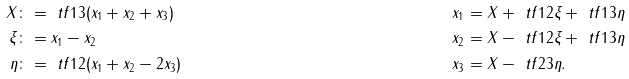Convert formula to latex. <formula><loc_0><loc_0><loc_500><loc_500>X & \colon = \ t f 1 3 ( x _ { 1 } + x _ { 2 } + x _ { 3 } ) & x _ { 1 } & = X + \ t f 1 2 \xi + \ t f 1 3 \eta \\ \xi & \colon = x _ { 1 } - x _ { 2 } & x _ { 2 } & = X - \ t f 1 2 \xi + \ t f 1 3 \eta \\ \eta & \colon = \ t f 1 2 ( x _ { 1 } + x _ { 2 } - 2 x _ { 3 } ) & x _ { 3 } & = X - \ t f 2 3 \eta .</formula> 